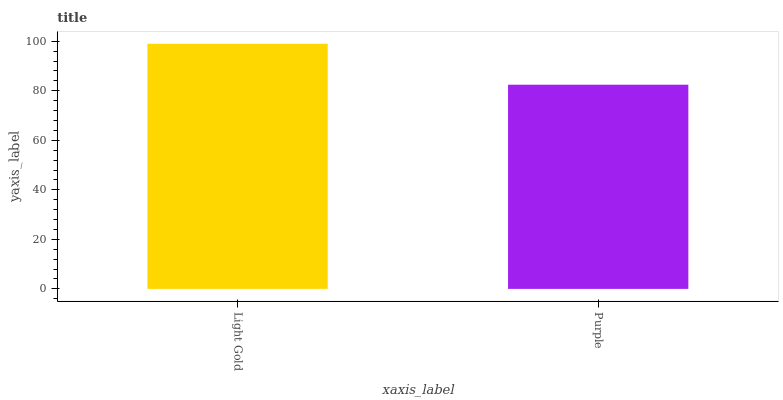Is Purple the maximum?
Answer yes or no. No. Is Light Gold greater than Purple?
Answer yes or no. Yes. Is Purple less than Light Gold?
Answer yes or no. Yes. Is Purple greater than Light Gold?
Answer yes or no. No. Is Light Gold less than Purple?
Answer yes or no. No. Is Light Gold the high median?
Answer yes or no. Yes. Is Purple the low median?
Answer yes or no. Yes. Is Purple the high median?
Answer yes or no. No. Is Light Gold the low median?
Answer yes or no. No. 